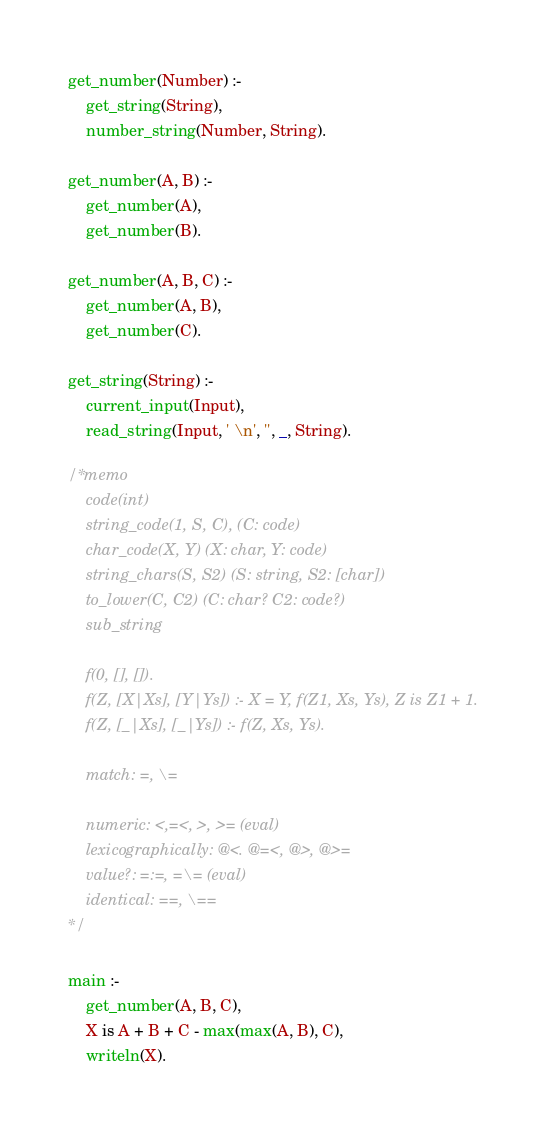Convert code to text. <code><loc_0><loc_0><loc_500><loc_500><_Prolog_>get_number(Number) :-
    get_string(String),
    number_string(Number, String).

get_number(A, B) :-
    get_number(A),
    get_number(B).

get_number(A, B, C) :-
    get_number(A, B),
    get_number(C).

get_string(String) :-
    current_input(Input),
    read_string(Input, ' \n', '', _, String).

/* memo
    code(int)
    string_code(1, S, C), (C: code)
    char_code(X, Y) (X: char, Y: code)
    string_chars(S, S2) (S: string, S2: [char])
    to_lower(C, C2) (C: char? C2: code?)
    sub_string

    f(0, [], []).
    f(Z, [X|Xs], [Y|Ys]) :- X = Y, f(Z1, Xs, Ys), Z is Z1 + 1.
    f(Z, [_|Xs], [_|Ys]) :- f(Z, Xs, Ys).

    match: =, \=

    numeric: <,=<, >, >= (eval)
    lexicographically: @<. @=<, @>, @>=
    value?: =:=, =\= (eval)
    identical: ==, \==
*/

main :-
    get_number(A, B, C),
    X is A + B + C - max(max(A, B), C),
    writeln(X).
</code> 